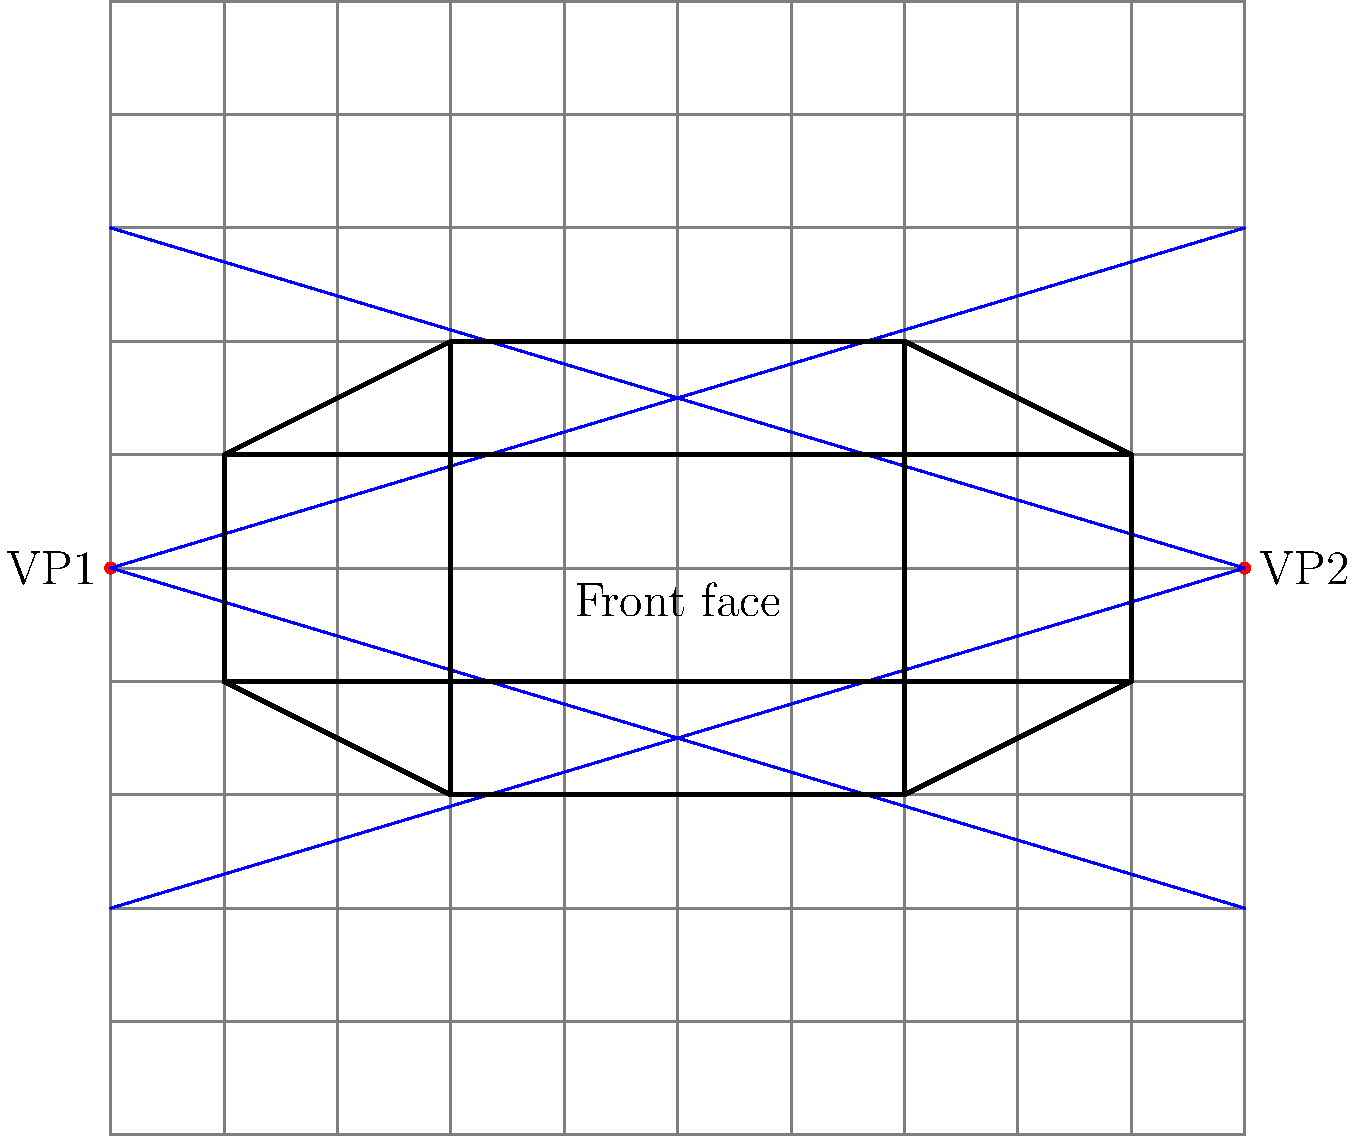In the given perspective drawing of a cube using two-point perspective, what is the significance of the points labeled VP1 and VP2, and how do they relate to the creation of depth and dimension in the drawing? To understand the significance of VP1 and VP2 in this two-point perspective drawing, let's break down the process:

1. VP1 and VP2 stand for Vanishing Point 1 and Vanishing Point 2, respectively. They are placed on the horizon line, which in this case is at $y=5$ on the grid.

2. Vanishing points are used to create the illusion of depth and dimension on a 2D surface. They represent the points where parallel lines appear to converge in the distance.

3. In this drawing:
   a) All horizontal lines parallel to the left-right axis converge at either VP1 or VP2.
   b) Vertical lines remain parallel and do not converge to either vanishing point.

4. The blue lines emanating from VP1 and VP2 are perspective lines. They guide the placement of the cube's edges to create a realistic 3D effect.

5. The front face of the cube is drawn as a perfect square because it's parallel to the picture plane. All other faces are distorted based on their orientation to the vanishing points.

6. Edges of the cube that recede towards the left converge at VP1, while those receding towards the right converge at VP2.

7. The placement of VP1 and VP2 affects the viewer's perceived angle to the object:
   a) Widely spaced vanishing points create a view closer to head-on.
   b) Closer vanishing points create a more angled view.

8. By using these vanishing points, the artist can maintain consistent perspective throughout the drawing, ensuring that all elements appear correctly scaled and positioned in 3D space.

This technique allows digital artists to recreate the depth and dimensionality achieved by traditional artists using pencil and paper, translating 3D concepts onto a 2D surface.
Answer: VP1 and VP2 are vanishing points that guide perspective lines, creating the illusion of depth and 3D space on a 2D surface. 